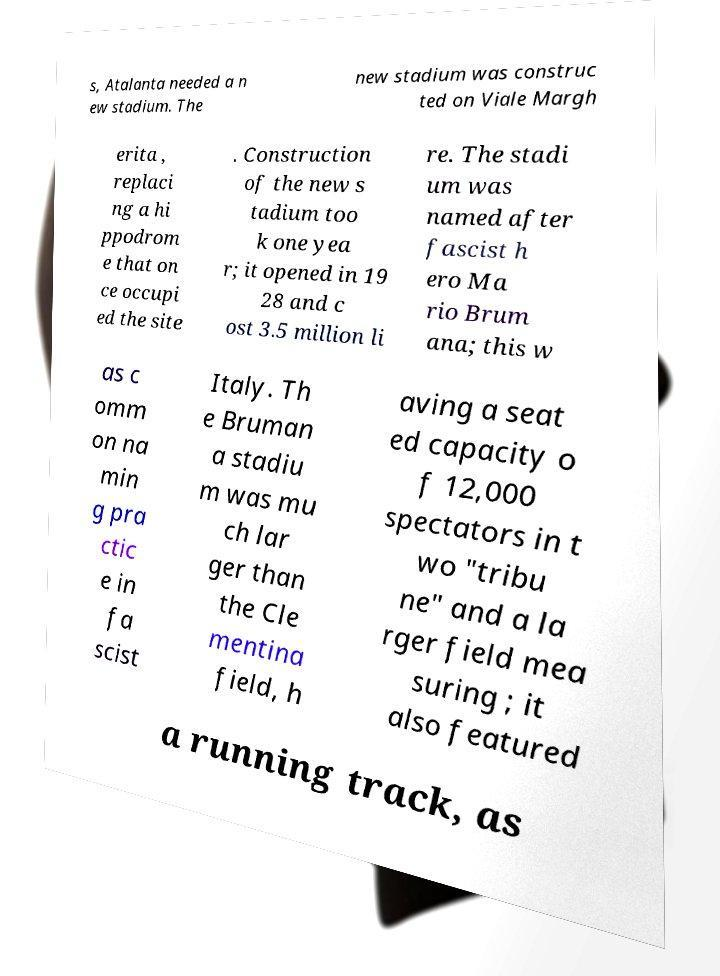Can you read and provide the text displayed in the image?This photo seems to have some interesting text. Can you extract and type it out for me? s, Atalanta needed a n ew stadium. The new stadium was construc ted on Viale Margh erita , replaci ng a hi ppodrom e that on ce occupi ed the site . Construction of the new s tadium too k one yea r; it opened in 19 28 and c ost 3.5 million li re. The stadi um was named after fascist h ero Ma rio Brum ana; this w as c omm on na min g pra ctic e in fa scist Italy. Th e Bruman a stadiu m was mu ch lar ger than the Cle mentina field, h aving a seat ed capacity o f 12,000 spectators in t wo "tribu ne" and a la rger field mea suring ; it also featured a running track, as 